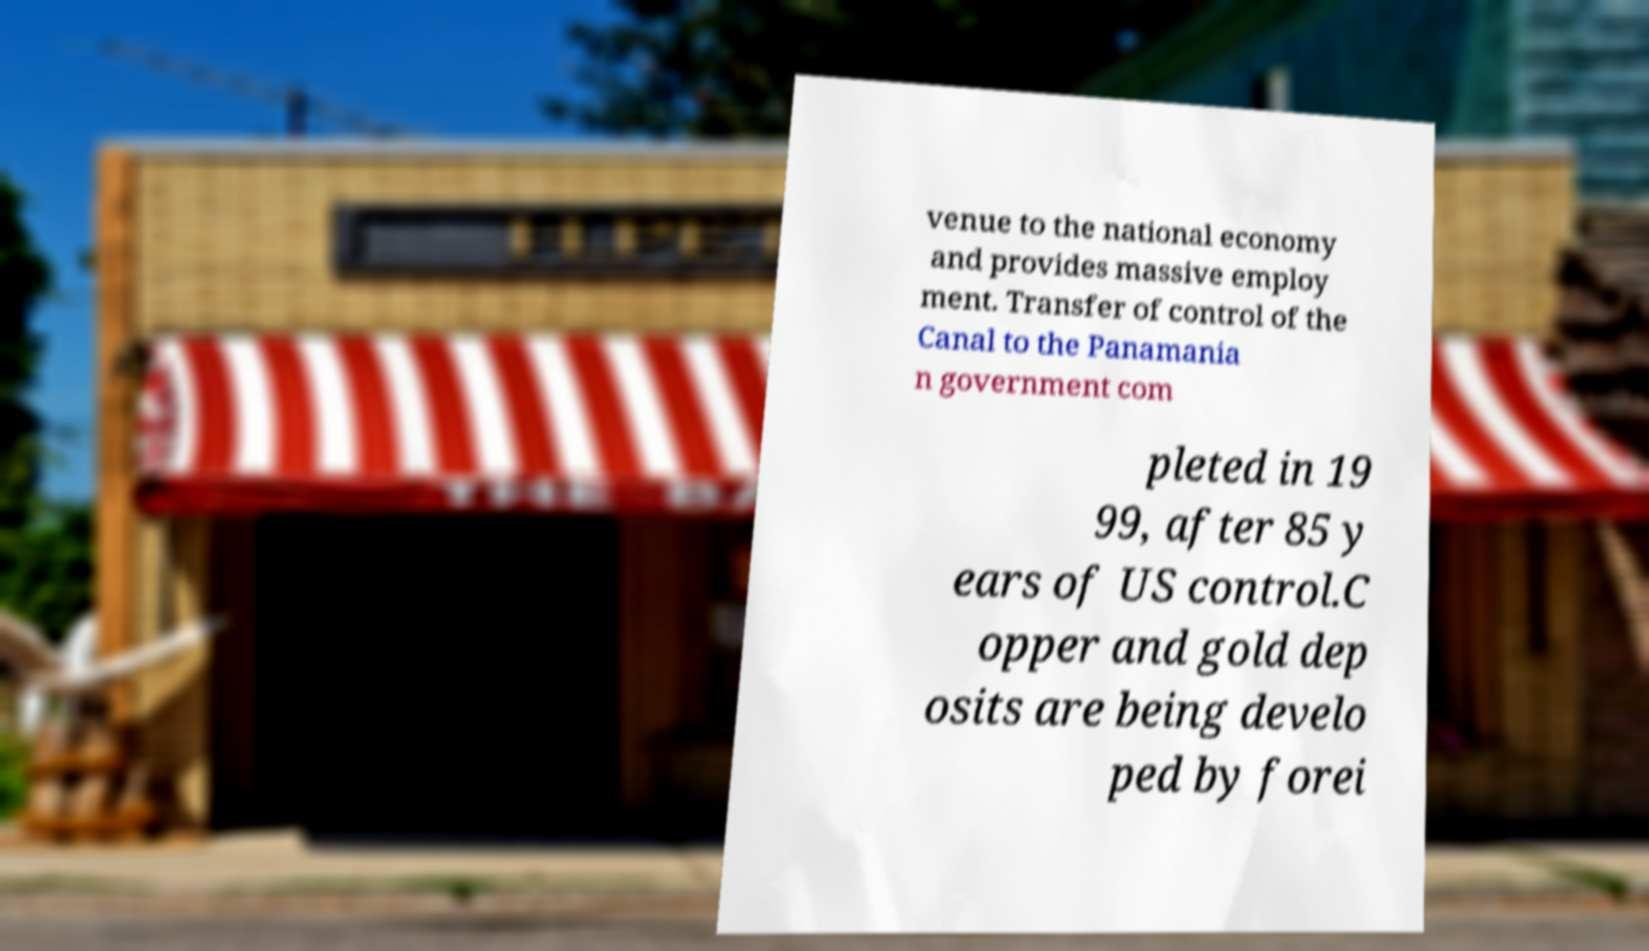Could you assist in decoding the text presented in this image and type it out clearly? venue to the national economy and provides massive employ ment. Transfer of control of the Canal to the Panamania n government com pleted in 19 99, after 85 y ears of US control.C opper and gold dep osits are being develo ped by forei 